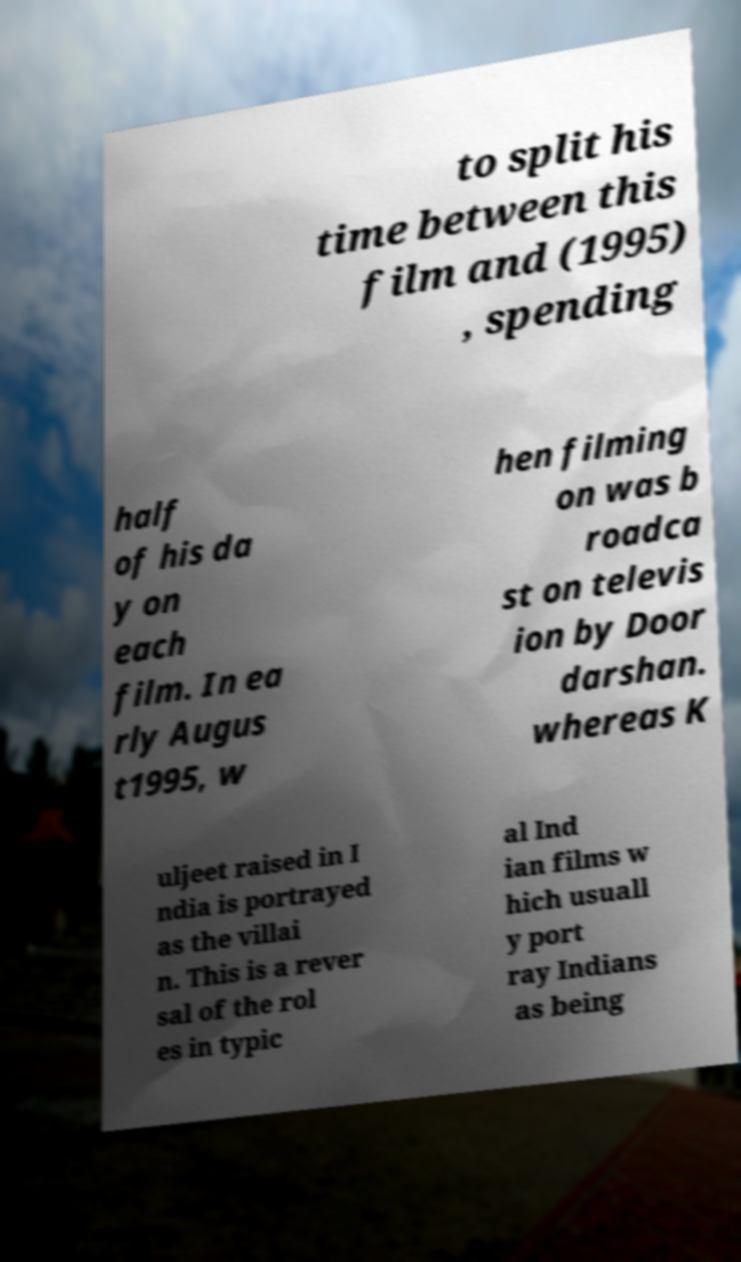Can you read and provide the text displayed in the image?This photo seems to have some interesting text. Can you extract and type it out for me? to split his time between this film and (1995) , spending half of his da y on each film. In ea rly Augus t1995, w hen filming on was b roadca st on televis ion by Door darshan. whereas K uljeet raised in I ndia is portrayed as the villai n. This is a rever sal of the rol es in typic al Ind ian films w hich usuall y port ray Indians as being 